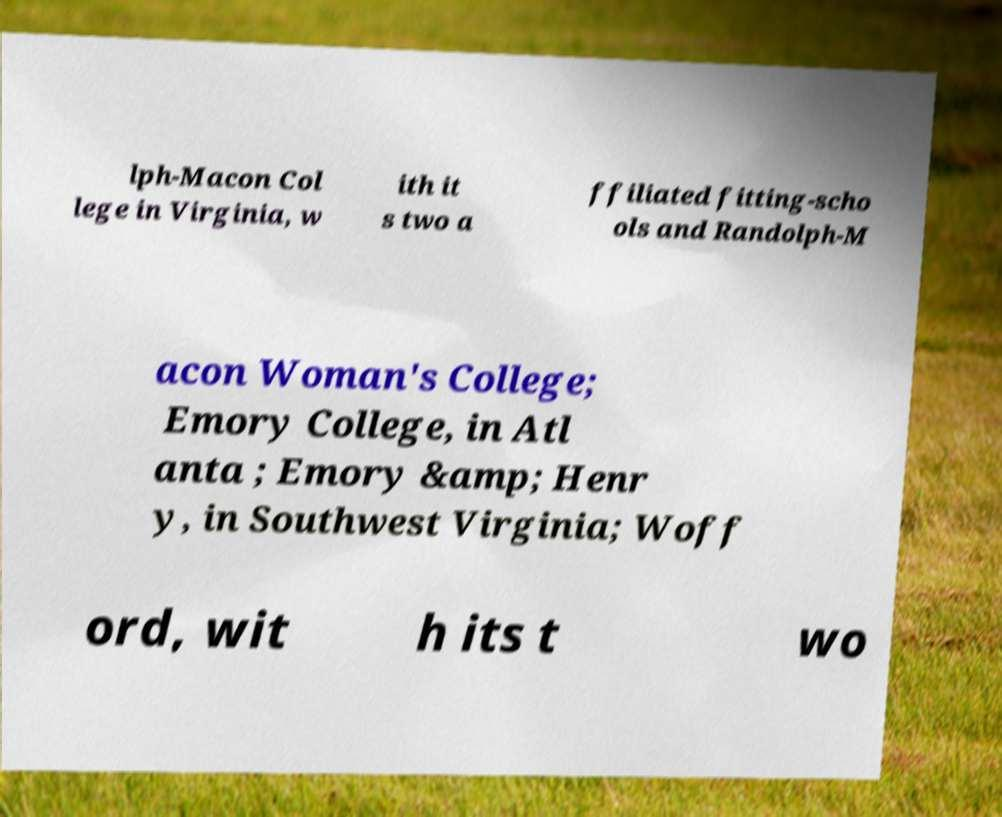Could you assist in decoding the text presented in this image and type it out clearly? lph-Macon Col lege in Virginia, w ith it s two a ffiliated fitting-scho ols and Randolph-M acon Woman's College; Emory College, in Atl anta ; Emory &amp; Henr y, in Southwest Virginia; Woff ord, wit h its t wo 